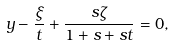Convert formula to latex. <formula><loc_0><loc_0><loc_500><loc_500>y - \frac { \xi } { t } + \frac { s \zeta } { 1 + s + s t } = 0 ,</formula> 